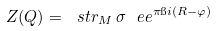<formula> <loc_0><loc_0><loc_500><loc_500>Z ( Q ) = \ s t r _ { M } \, \sigma \ e e ^ { \pi \i i ( R - \varphi ) }</formula> 